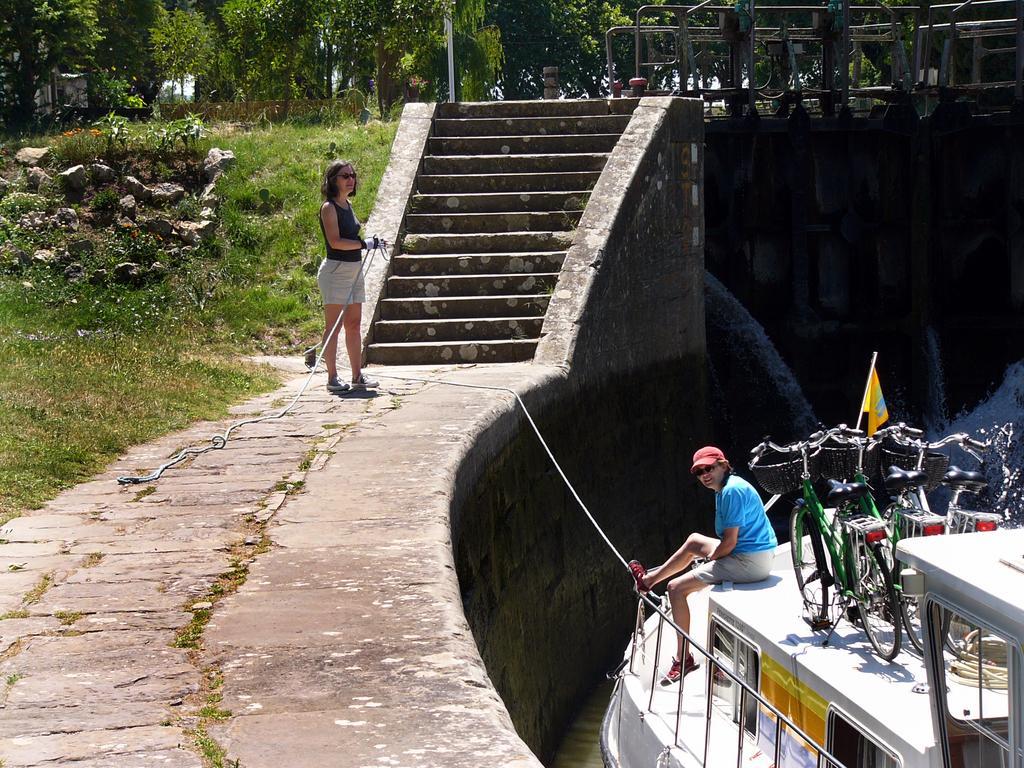Describe this image in one or two sentences. In this image there is a bridge, on the it there are some steps, woman holding a rope visible on the bridge, in the bottom right there is the lake, on which there is a boat, on which there is a person, bicycles, in the top left there are trees, stones, grass visible. 